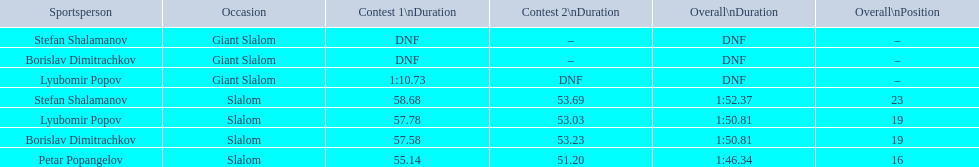What were the event names during bulgaria at the 1988 winter olympics? Stefan Shalamanov, Borislav Dimitrachkov, Lyubomir Popov. And which players participated at giant slalom? Giant Slalom, Giant Slalom, Giant Slalom, Slalom, Slalom, Slalom, Slalom. What were their race 1 times? DNF, DNF, 1:10.73. What was lyubomir popov's personal time? 1:10.73. 